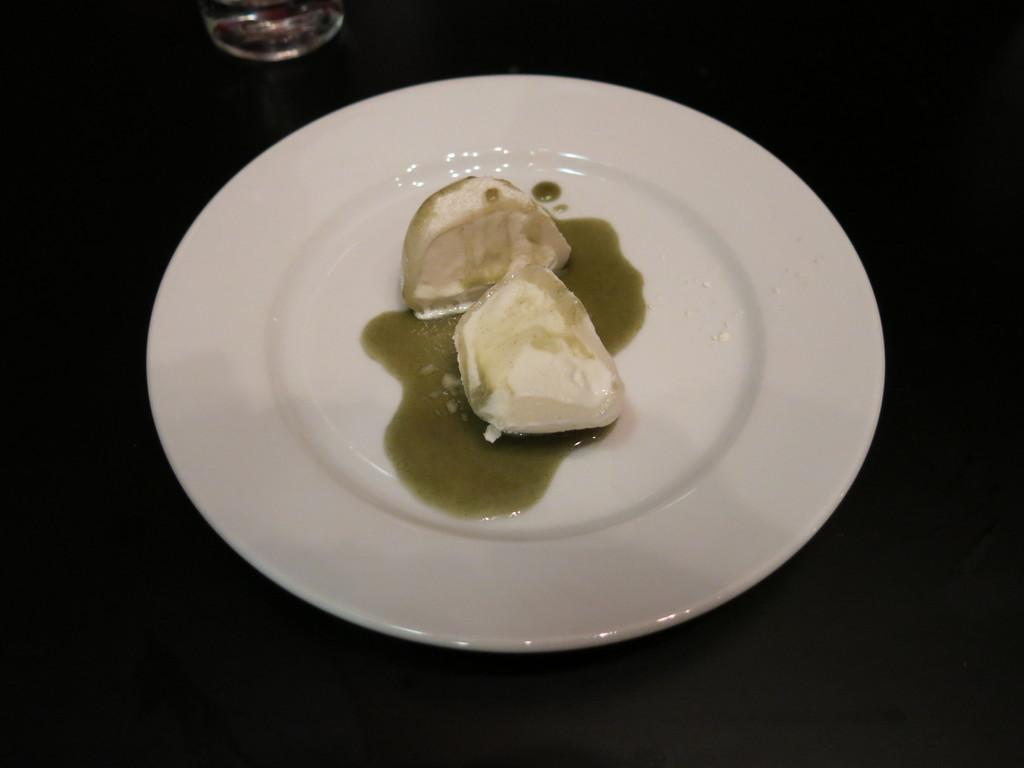What is on the plate in the image? There is food in the plate in the image. What can be seen on the table besides the plate? There is a glass on the table in the image. What type of whistle can be heard in the image? There is no whistle present in the image, so it cannot be heard. 